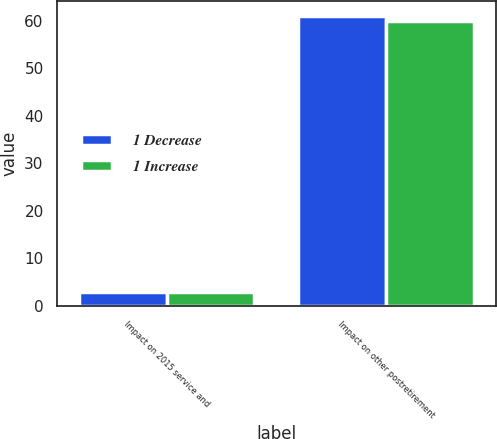Convert chart. <chart><loc_0><loc_0><loc_500><loc_500><stacked_bar_chart><ecel><fcel>Impact on 2015 service and<fcel>Impact on other postretirement<nl><fcel>1 Decrease<fcel>3<fcel>61<nl><fcel>1 Increase<fcel>3<fcel>60<nl></chart> 